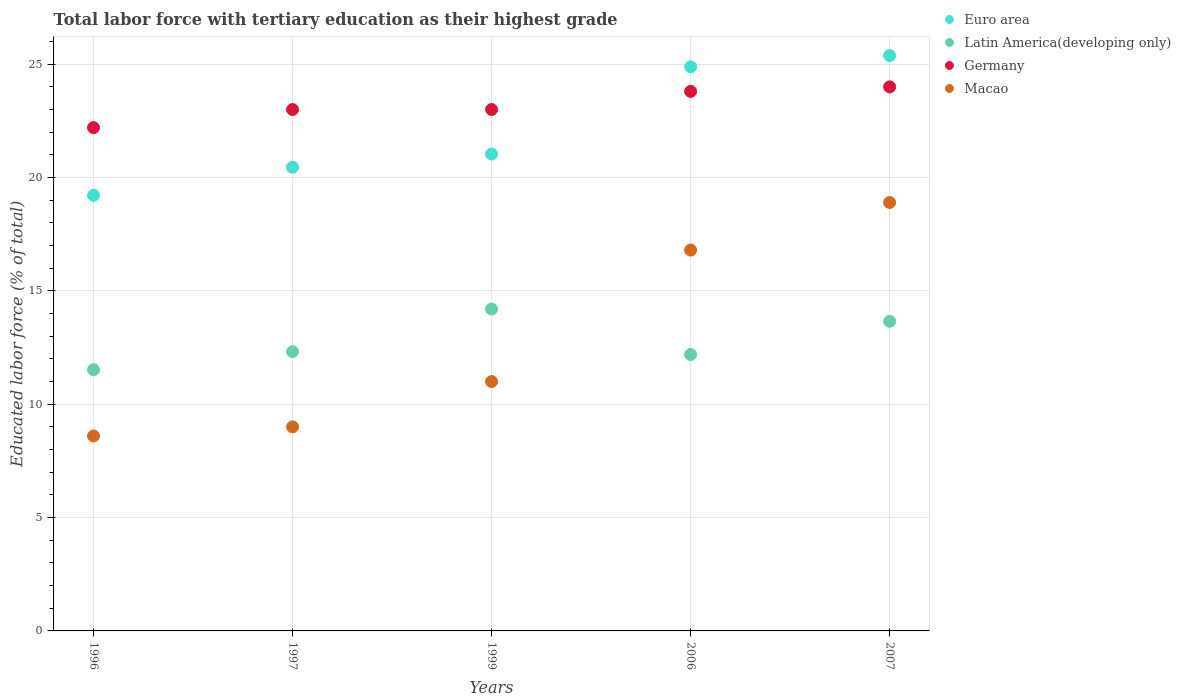How many different coloured dotlines are there?
Ensure brevity in your answer.  4. What is the percentage of male labor force with tertiary education in Latin America(developing only) in 1997?
Keep it short and to the point. 12.32. Across all years, what is the maximum percentage of male labor force with tertiary education in Macao?
Give a very brief answer. 18.9. Across all years, what is the minimum percentage of male labor force with tertiary education in Latin America(developing only)?
Keep it short and to the point. 11.52. In which year was the percentage of male labor force with tertiary education in Latin America(developing only) minimum?
Make the answer very short. 1996. What is the total percentage of male labor force with tertiary education in Euro area in the graph?
Make the answer very short. 110.97. What is the difference between the percentage of male labor force with tertiary education in Latin America(developing only) in 1996 and that in 2007?
Provide a short and direct response. -2.13. What is the difference between the percentage of male labor force with tertiary education in Latin America(developing only) in 1997 and the percentage of male labor force with tertiary education in Macao in 1996?
Your answer should be very brief. 3.72. What is the average percentage of male labor force with tertiary education in Latin America(developing only) per year?
Keep it short and to the point. 12.78. In the year 2006, what is the difference between the percentage of male labor force with tertiary education in Euro area and percentage of male labor force with tertiary education in Macao?
Make the answer very short. 8.08. What is the ratio of the percentage of male labor force with tertiary education in Germany in 1999 to that in 2006?
Your answer should be compact. 0.97. Is the percentage of male labor force with tertiary education in Euro area in 1997 less than that in 2006?
Provide a short and direct response. Yes. Is the difference between the percentage of male labor force with tertiary education in Euro area in 1996 and 2006 greater than the difference between the percentage of male labor force with tertiary education in Macao in 1996 and 2006?
Keep it short and to the point. Yes. What is the difference between the highest and the second highest percentage of male labor force with tertiary education in Latin America(developing only)?
Your answer should be very brief. 0.54. What is the difference between the highest and the lowest percentage of male labor force with tertiary education in Macao?
Provide a succinct answer. 10.3. Is it the case that in every year, the sum of the percentage of male labor force with tertiary education in Euro area and percentage of male labor force with tertiary education in Germany  is greater than the sum of percentage of male labor force with tertiary education in Latin America(developing only) and percentage of male labor force with tertiary education in Macao?
Your response must be concise. Yes. Is it the case that in every year, the sum of the percentage of male labor force with tertiary education in Germany and percentage of male labor force with tertiary education in Euro area  is greater than the percentage of male labor force with tertiary education in Macao?
Your answer should be very brief. Yes. Does the percentage of male labor force with tertiary education in Germany monotonically increase over the years?
Your response must be concise. No. Is the percentage of male labor force with tertiary education in Euro area strictly less than the percentage of male labor force with tertiary education in Macao over the years?
Keep it short and to the point. No. Are the values on the major ticks of Y-axis written in scientific E-notation?
Your answer should be very brief. No. Does the graph contain any zero values?
Your answer should be compact. No. Where does the legend appear in the graph?
Your answer should be very brief. Top right. What is the title of the graph?
Make the answer very short. Total labor force with tertiary education as their highest grade. What is the label or title of the X-axis?
Give a very brief answer. Years. What is the label or title of the Y-axis?
Keep it short and to the point. Educated labor force (% of total). What is the Educated labor force (% of total) of Euro area in 1996?
Keep it short and to the point. 19.22. What is the Educated labor force (% of total) in Latin America(developing only) in 1996?
Make the answer very short. 11.52. What is the Educated labor force (% of total) in Germany in 1996?
Give a very brief answer. 22.2. What is the Educated labor force (% of total) in Macao in 1996?
Make the answer very short. 8.6. What is the Educated labor force (% of total) in Euro area in 1997?
Provide a short and direct response. 20.46. What is the Educated labor force (% of total) of Latin America(developing only) in 1997?
Make the answer very short. 12.32. What is the Educated labor force (% of total) of Germany in 1997?
Provide a succinct answer. 23. What is the Educated labor force (% of total) of Macao in 1997?
Keep it short and to the point. 9. What is the Educated labor force (% of total) of Euro area in 1999?
Ensure brevity in your answer.  21.03. What is the Educated labor force (% of total) in Latin America(developing only) in 1999?
Keep it short and to the point. 14.2. What is the Educated labor force (% of total) in Germany in 1999?
Your answer should be very brief. 23. What is the Educated labor force (% of total) in Macao in 1999?
Your response must be concise. 11. What is the Educated labor force (% of total) in Euro area in 2006?
Provide a short and direct response. 24.88. What is the Educated labor force (% of total) in Latin America(developing only) in 2006?
Your response must be concise. 12.19. What is the Educated labor force (% of total) in Germany in 2006?
Provide a succinct answer. 23.8. What is the Educated labor force (% of total) in Macao in 2006?
Offer a terse response. 16.8. What is the Educated labor force (% of total) of Euro area in 2007?
Offer a very short reply. 25.38. What is the Educated labor force (% of total) in Latin America(developing only) in 2007?
Ensure brevity in your answer.  13.66. What is the Educated labor force (% of total) in Germany in 2007?
Offer a terse response. 24. What is the Educated labor force (% of total) in Macao in 2007?
Provide a short and direct response. 18.9. Across all years, what is the maximum Educated labor force (% of total) of Euro area?
Your answer should be very brief. 25.38. Across all years, what is the maximum Educated labor force (% of total) of Latin America(developing only)?
Offer a terse response. 14.2. Across all years, what is the maximum Educated labor force (% of total) in Macao?
Offer a terse response. 18.9. Across all years, what is the minimum Educated labor force (% of total) of Euro area?
Provide a short and direct response. 19.22. Across all years, what is the minimum Educated labor force (% of total) of Latin America(developing only)?
Make the answer very short. 11.52. Across all years, what is the minimum Educated labor force (% of total) in Germany?
Offer a terse response. 22.2. Across all years, what is the minimum Educated labor force (% of total) in Macao?
Ensure brevity in your answer.  8.6. What is the total Educated labor force (% of total) in Euro area in the graph?
Your answer should be very brief. 110.97. What is the total Educated labor force (% of total) in Latin America(developing only) in the graph?
Provide a succinct answer. 63.89. What is the total Educated labor force (% of total) in Germany in the graph?
Give a very brief answer. 116. What is the total Educated labor force (% of total) of Macao in the graph?
Offer a very short reply. 64.3. What is the difference between the Educated labor force (% of total) in Euro area in 1996 and that in 1997?
Give a very brief answer. -1.24. What is the difference between the Educated labor force (% of total) in Latin America(developing only) in 1996 and that in 1997?
Ensure brevity in your answer.  -0.8. What is the difference between the Educated labor force (% of total) of Germany in 1996 and that in 1997?
Offer a very short reply. -0.8. What is the difference between the Educated labor force (% of total) of Macao in 1996 and that in 1997?
Your response must be concise. -0.4. What is the difference between the Educated labor force (% of total) in Euro area in 1996 and that in 1999?
Make the answer very short. -1.82. What is the difference between the Educated labor force (% of total) in Latin America(developing only) in 1996 and that in 1999?
Your response must be concise. -2.68. What is the difference between the Educated labor force (% of total) of Euro area in 1996 and that in 2006?
Your answer should be very brief. -5.67. What is the difference between the Educated labor force (% of total) in Latin America(developing only) in 1996 and that in 2006?
Your response must be concise. -0.67. What is the difference between the Educated labor force (% of total) of Germany in 1996 and that in 2006?
Ensure brevity in your answer.  -1.6. What is the difference between the Educated labor force (% of total) of Macao in 1996 and that in 2006?
Keep it short and to the point. -8.2. What is the difference between the Educated labor force (% of total) in Euro area in 1996 and that in 2007?
Provide a short and direct response. -6.16. What is the difference between the Educated labor force (% of total) in Latin America(developing only) in 1996 and that in 2007?
Your response must be concise. -2.13. What is the difference between the Educated labor force (% of total) of Germany in 1996 and that in 2007?
Provide a short and direct response. -1.8. What is the difference between the Educated labor force (% of total) in Euro area in 1997 and that in 1999?
Provide a short and direct response. -0.58. What is the difference between the Educated labor force (% of total) in Latin America(developing only) in 1997 and that in 1999?
Offer a very short reply. -1.88. What is the difference between the Educated labor force (% of total) of Euro area in 1997 and that in 2006?
Give a very brief answer. -4.43. What is the difference between the Educated labor force (% of total) of Latin America(developing only) in 1997 and that in 2006?
Offer a very short reply. 0.13. What is the difference between the Educated labor force (% of total) of Euro area in 1997 and that in 2007?
Ensure brevity in your answer.  -4.92. What is the difference between the Educated labor force (% of total) in Latin America(developing only) in 1997 and that in 2007?
Give a very brief answer. -1.34. What is the difference between the Educated labor force (% of total) in Euro area in 1999 and that in 2006?
Provide a succinct answer. -3.85. What is the difference between the Educated labor force (% of total) in Latin America(developing only) in 1999 and that in 2006?
Give a very brief answer. 2.01. What is the difference between the Educated labor force (% of total) in Euro area in 1999 and that in 2007?
Offer a terse response. -4.34. What is the difference between the Educated labor force (% of total) in Latin America(developing only) in 1999 and that in 2007?
Provide a succinct answer. 0.54. What is the difference between the Educated labor force (% of total) in Euro area in 2006 and that in 2007?
Give a very brief answer. -0.49. What is the difference between the Educated labor force (% of total) in Latin America(developing only) in 2006 and that in 2007?
Ensure brevity in your answer.  -1.46. What is the difference between the Educated labor force (% of total) in Macao in 2006 and that in 2007?
Provide a short and direct response. -2.1. What is the difference between the Educated labor force (% of total) of Euro area in 1996 and the Educated labor force (% of total) of Latin America(developing only) in 1997?
Provide a succinct answer. 6.9. What is the difference between the Educated labor force (% of total) of Euro area in 1996 and the Educated labor force (% of total) of Germany in 1997?
Offer a terse response. -3.78. What is the difference between the Educated labor force (% of total) in Euro area in 1996 and the Educated labor force (% of total) in Macao in 1997?
Ensure brevity in your answer.  10.22. What is the difference between the Educated labor force (% of total) in Latin America(developing only) in 1996 and the Educated labor force (% of total) in Germany in 1997?
Your answer should be very brief. -11.48. What is the difference between the Educated labor force (% of total) of Latin America(developing only) in 1996 and the Educated labor force (% of total) of Macao in 1997?
Make the answer very short. 2.52. What is the difference between the Educated labor force (% of total) of Euro area in 1996 and the Educated labor force (% of total) of Latin America(developing only) in 1999?
Make the answer very short. 5.02. What is the difference between the Educated labor force (% of total) of Euro area in 1996 and the Educated labor force (% of total) of Germany in 1999?
Ensure brevity in your answer.  -3.78. What is the difference between the Educated labor force (% of total) of Euro area in 1996 and the Educated labor force (% of total) of Macao in 1999?
Provide a short and direct response. 8.22. What is the difference between the Educated labor force (% of total) of Latin America(developing only) in 1996 and the Educated labor force (% of total) of Germany in 1999?
Provide a succinct answer. -11.48. What is the difference between the Educated labor force (% of total) of Latin America(developing only) in 1996 and the Educated labor force (% of total) of Macao in 1999?
Your response must be concise. 0.52. What is the difference between the Educated labor force (% of total) of Euro area in 1996 and the Educated labor force (% of total) of Latin America(developing only) in 2006?
Make the answer very short. 7.02. What is the difference between the Educated labor force (% of total) in Euro area in 1996 and the Educated labor force (% of total) in Germany in 2006?
Offer a terse response. -4.58. What is the difference between the Educated labor force (% of total) in Euro area in 1996 and the Educated labor force (% of total) in Macao in 2006?
Give a very brief answer. 2.42. What is the difference between the Educated labor force (% of total) of Latin America(developing only) in 1996 and the Educated labor force (% of total) of Germany in 2006?
Ensure brevity in your answer.  -12.28. What is the difference between the Educated labor force (% of total) in Latin America(developing only) in 1996 and the Educated labor force (% of total) in Macao in 2006?
Your answer should be very brief. -5.28. What is the difference between the Educated labor force (% of total) of Euro area in 1996 and the Educated labor force (% of total) of Latin America(developing only) in 2007?
Your answer should be very brief. 5.56. What is the difference between the Educated labor force (% of total) in Euro area in 1996 and the Educated labor force (% of total) in Germany in 2007?
Offer a very short reply. -4.78. What is the difference between the Educated labor force (% of total) in Euro area in 1996 and the Educated labor force (% of total) in Macao in 2007?
Your answer should be compact. 0.32. What is the difference between the Educated labor force (% of total) in Latin America(developing only) in 1996 and the Educated labor force (% of total) in Germany in 2007?
Offer a terse response. -12.48. What is the difference between the Educated labor force (% of total) of Latin America(developing only) in 1996 and the Educated labor force (% of total) of Macao in 2007?
Keep it short and to the point. -7.38. What is the difference between the Educated labor force (% of total) of Germany in 1996 and the Educated labor force (% of total) of Macao in 2007?
Your answer should be very brief. 3.3. What is the difference between the Educated labor force (% of total) in Euro area in 1997 and the Educated labor force (% of total) in Latin America(developing only) in 1999?
Offer a very short reply. 6.26. What is the difference between the Educated labor force (% of total) of Euro area in 1997 and the Educated labor force (% of total) of Germany in 1999?
Your response must be concise. -2.54. What is the difference between the Educated labor force (% of total) in Euro area in 1997 and the Educated labor force (% of total) in Macao in 1999?
Offer a terse response. 9.46. What is the difference between the Educated labor force (% of total) of Latin America(developing only) in 1997 and the Educated labor force (% of total) of Germany in 1999?
Provide a short and direct response. -10.68. What is the difference between the Educated labor force (% of total) of Latin America(developing only) in 1997 and the Educated labor force (% of total) of Macao in 1999?
Offer a terse response. 1.32. What is the difference between the Educated labor force (% of total) of Germany in 1997 and the Educated labor force (% of total) of Macao in 1999?
Give a very brief answer. 12. What is the difference between the Educated labor force (% of total) in Euro area in 1997 and the Educated labor force (% of total) in Latin America(developing only) in 2006?
Offer a very short reply. 8.26. What is the difference between the Educated labor force (% of total) of Euro area in 1997 and the Educated labor force (% of total) of Germany in 2006?
Your answer should be very brief. -3.34. What is the difference between the Educated labor force (% of total) in Euro area in 1997 and the Educated labor force (% of total) in Macao in 2006?
Offer a terse response. 3.66. What is the difference between the Educated labor force (% of total) of Latin America(developing only) in 1997 and the Educated labor force (% of total) of Germany in 2006?
Offer a terse response. -11.48. What is the difference between the Educated labor force (% of total) of Latin America(developing only) in 1997 and the Educated labor force (% of total) of Macao in 2006?
Your response must be concise. -4.48. What is the difference between the Educated labor force (% of total) of Euro area in 1997 and the Educated labor force (% of total) of Latin America(developing only) in 2007?
Offer a terse response. 6.8. What is the difference between the Educated labor force (% of total) in Euro area in 1997 and the Educated labor force (% of total) in Germany in 2007?
Offer a terse response. -3.54. What is the difference between the Educated labor force (% of total) in Euro area in 1997 and the Educated labor force (% of total) in Macao in 2007?
Ensure brevity in your answer.  1.56. What is the difference between the Educated labor force (% of total) of Latin America(developing only) in 1997 and the Educated labor force (% of total) of Germany in 2007?
Provide a short and direct response. -11.68. What is the difference between the Educated labor force (% of total) in Latin America(developing only) in 1997 and the Educated labor force (% of total) in Macao in 2007?
Provide a succinct answer. -6.58. What is the difference between the Educated labor force (% of total) of Germany in 1997 and the Educated labor force (% of total) of Macao in 2007?
Make the answer very short. 4.1. What is the difference between the Educated labor force (% of total) of Euro area in 1999 and the Educated labor force (% of total) of Latin America(developing only) in 2006?
Your response must be concise. 8.84. What is the difference between the Educated labor force (% of total) of Euro area in 1999 and the Educated labor force (% of total) of Germany in 2006?
Your answer should be very brief. -2.77. What is the difference between the Educated labor force (% of total) of Euro area in 1999 and the Educated labor force (% of total) of Macao in 2006?
Your answer should be compact. 4.23. What is the difference between the Educated labor force (% of total) in Latin America(developing only) in 1999 and the Educated labor force (% of total) in Germany in 2006?
Make the answer very short. -9.6. What is the difference between the Educated labor force (% of total) of Latin America(developing only) in 1999 and the Educated labor force (% of total) of Macao in 2006?
Your answer should be very brief. -2.6. What is the difference between the Educated labor force (% of total) in Germany in 1999 and the Educated labor force (% of total) in Macao in 2006?
Keep it short and to the point. 6.2. What is the difference between the Educated labor force (% of total) in Euro area in 1999 and the Educated labor force (% of total) in Latin America(developing only) in 2007?
Provide a short and direct response. 7.38. What is the difference between the Educated labor force (% of total) in Euro area in 1999 and the Educated labor force (% of total) in Germany in 2007?
Ensure brevity in your answer.  -2.97. What is the difference between the Educated labor force (% of total) in Euro area in 1999 and the Educated labor force (% of total) in Macao in 2007?
Offer a very short reply. 2.13. What is the difference between the Educated labor force (% of total) in Latin America(developing only) in 1999 and the Educated labor force (% of total) in Germany in 2007?
Keep it short and to the point. -9.8. What is the difference between the Educated labor force (% of total) of Latin America(developing only) in 1999 and the Educated labor force (% of total) of Macao in 2007?
Offer a very short reply. -4.7. What is the difference between the Educated labor force (% of total) in Euro area in 2006 and the Educated labor force (% of total) in Latin America(developing only) in 2007?
Provide a short and direct response. 11.23. What is the difference between the Educated labor force (% of total) in Euro area in 2006 and the Educated labor force (% of total) in Germany in 2007?
Offer a terse response. 0.88. What is the difference between the Educated labor force (% of total) in Euro area in 2006 and the Educated labor force (% of total) in Macao in 2007?
Your answer should be compact. 5.98. What is the difference between the Educated labor force (% of total) of Latin America(developing only) in 2006 and the Educated labor force (% of total) of Germany in 2007?
Ensure brevity in your answer.  -11.81. What is the difference between the Educated labor force (% of total) of Latin America(developing only) in 2006 and the Educated labor force (% of total) of Macao in 2007?
Keep it short and to the point. -6.71. What is the average Educated labor force (% of total) in Euro area per year?
Your response must be concise. 22.19. What is the average Educated labor force (% of total) in Latin America(developing only) per year?
Provide a succinct answer. 12.78. What is the average Educated labor force (% of total) in Germany per year?
Ensure brevity in your answer.  23.2. What is the average Educated labor force (% of total) in Macao per year?
Your answer should be very brief. 12.86. In the year 1996, what is the difference between the Educated labor force (% of total) in Euro area and Educated labor force (% of total) in Latin America(developing only)?
Keep it short and to the point. 7.69. In the year 1996, what is the difference between the Educated labor force (% of total) of Euro area and Educated labor force (% of total) of Germany?
Offer a terse response. -2.98. In the year 1996, what is the difference between the Educated labor force (% of total) of Euro area and Educated labor force (% of total) of Macao?
Provide a short and direct response. 10.62. In the year 1996, what is the difference between the Educated labor force (% of total) in Latin America(developing only) and Educated labor force (% of total) in Germany?
Give a very brief answer. -10.68. In the year 1996, what is the difference between the Educated labor force (% of total) of Latin America(developing only) and Educated labor force (% of total) of Macao?
Provide a succinct answer. 2.92. In the year 1997, what is the difference between the Educated labor force (% of total) in Euro area and Educated labor force (% of total) in Latin America(developing only)?
Your response must be concise. 8.14. In the year 1997, what is the difference between the Educated labor force (% of total) in Euro area and Educated labor force (% of total) in Germany?
Ensure brevity in your answer.  -2.54. In the year 1997, what is the difference between the Educated labor force (% of total) of Euro area and Educated labor force (% of total) of Macao?
Keep it short and to the point. 11.46. In the year 1997, what is the difference between the Educated labor force (% of total) in Latin America(developing only) and Educated labor force (% of total) in Germany?
Provide a short and direct response. -10.68. In the year 1997, what is the difference between the Educated labor force (% of total) of Latin America(developing only) and Educated labor force (% of total) of Macao?
Provide a short and direct response. 3.32. In the year 1999, what is the difference between the Educated labor force (% of total) in Euro area and Educated labor force (% of total) in Latin America(developing only)?
Your answer should be compact. 6.84. In the year 1999, what is the difference between the Educated labor force (% of total) of Euro area and Educated labor force (% of total) of Germany?
Your answer should be very brief. -1.97. In the year 1999, what is the difference between the Educated labor force (% of total) in Euro area and Educated labor force (% of total) in Macao?
Provide a succinct answer. 10.03. In the year 1999, what is the difference between the Educated labor force (% of total) in Latin America(developing only) and Educated labor force (% of total) in Germany?
Your response must be concise. -8.8. In the year 1999, what is the difference between the Educated labor force (% of total) of Latin America(developing only) and Educated labor force (% of total) of Macao?
Provide a succinct answer. 3.2. In the year 2006, what is the difference between the Educated labor force (% of total) in Euro area and Educated labor force (% of total) in Latin America(developing only)?
Offer a very short reply. 12.69. In the year 2006, what is the difference between the Educated labor force (% of total) in Euro area and Educated labor force (% of total) in Germany?
Offer a terse response. 1.08. In the year 2006, what is the difference between the Educated labor force (% of total) in Euro area and Educated labor force (% of total) in Macao?
Ensure brevity in your answer.  8.08. In the year 2006, what is the difference between the Educated labor force (% of total) in Latin America(developing only) and Educated labor force (% of total) in Germany?
Give a very brief answer. -11.61. In the year 2006, what is the difference between the Educated labor force (% of total) in Latin America(developing only) and Educated labor force (% of total) in Macao?
Provide a succinct answer. -4.61. In the year 2007, what is the difference between the Educated labor force (% of total) in Euro area and Educated labor force (% of total) in Latin America(developing only)?
Your response must be concise. 11.72. In the year 2007, what is the difference between the Educated labor force (% of total) of Euro area and Educated labor force (% of total) of Germany?
Keep it short and to the point. 1.38. In the year 2007, what is the difference between the Educated labor force (% of total) of Euro area and Educated labor force (% of total) of Macao?
Provide a short and direct response. 6.48. In the year 2007, what is the difference between the Educated labor force (% of total) in Latin America(developing only) and Educated labor force (% of total) in Germany?
Give a very brief answer. -10.34. In the year 2007, what is the difference between the Educated labor force (% of total) in Latin America(developing only) and Educated labor force (% of total) in Macao?
Your answer should be very brief. -5.24. In the year 2007, what is the difference between the Educated labor force (% of total) of Germany and Educated labor force (% of total) of Macao?
Provide a succinct answer. 5.1. What is the ratio of the Educated labor force (% of total) of Euro area in 1996 to that in 1997?
Your response must be concise. 0.94. What is the ratio of the Educated labor force (% of total) in Latin America(developing only) in 1996 to that in 1997?
Give a very brief answer. 0.94. What is the ratio of the Educated labor force (% of total) in Germany in 1996 to that in 1997?
Keep it short and to the point. 0.97. What is the ratio of the Educated labor force (% of total) in Macao in 1996 to that in 1997?
Your answer should be compact. 0.96. What is the ratio of the Educated labor force (% of total) in Euro area in 1996 to that in 1999?
Offer a very short reply. 0.91. What is the ratio of the Educated labor force (% of total) of Latin America(developing only) in 1996 to that in 1999?
Your answer should be compact. 0.81. What is the ratio of the Educated labor force (% of total) of Germany in 1996 to that in 1999?
Offer a terse response. 0.97. What is the ratio of the Educated labor force (% of total) of Macao in 1996 to that in 1999?
Your response must be concise. 0.78. What is the ratio of the Educated labor force (% of total) in Euro area in 1996 to that in 2006?
Offer a terse response. 0.77. What is the ratio of the Educated labor force (% of total) in Latin America(developing only) in 1996 to that in 2006?
Give a very brief answer. 0.95. What is the ratio of the Educated labor force (% of total) of Germany in 1996 to that in 2006?
Ensure brevity in your answer.  0.93. What is the ratio of the Educated labor force (% of total) in Macao in 1996 to that in 2006?
Offer a terse response. 0.51. What is the ratio of the Educated labor force (% of total) of Euro area in 1996 to that in 2007?
Keep it short and to the point. 0.76. What is the ratio of the Educated labor force (% of total) of Latin America(developing only) in 1996 to that in 2007?
Your response must be concise. 0.84. What is the ratio of the Educated labor force (% of total) of Germany in 1996 to that in 2007?
Ensure brevity in your answer.  0.93. What is the ratio of the Educated labor force (% of total) in Macao in 1996 to that in 2007?
Your answer should be compact. 0.46. What is the ratio of the Educated labor force (% of total) in Euro area in 1997 to that in 1999?
Offer a terse response. 0.97. What is the ratio of the Educated labor force (% of total) in Latin America(developing only) in 1997 to that in 1999?
Your response must be concise. 0.87. What is the ratio of the Educated labor force (% of total) in Macao in 1997 to that in 1999?
Provide a succinct answer. 0.82. What is the ratio of the Educated labor force (% of total) of Euro area in 1997 to that in 2006?
Provide a succinct answer. 0.82. What is the ratio of the Educated labor force (% of total) of Latin America(developing only) in 1997 to that in 2006?
Provide a short and direct response. 1.01. What is the ratio of the Educated labor force (% of total) in Germany in 1997 to that in 2006?
Your answer should be compact. 0.97. What is the ratio of the Educated labor force (% of total) in Macao in 1997 to that in 2006?
Offer a very short reply. 0.54. What is the ratio of the Educated labor force (% of total) of Euro area in 1997 to that in 2007?
Your response must be concise. 0.81. What is the ratio of the Educated labor force (% of total) in Latin America(developing only) in 1997 to that in 2007?
Your answer should be very brief. 0.9. What is the ratio of the Educated labor force (% of total) in Macao in 1997 to that in 2007?
Provide a succinct answer. 0.48. What is the ratio of the Educated labor force (% of total) in Euro area in 1999 to that in 2006?
Make the answer very short. 0.85. What is the ratio of the Educated labor force (% of total) of Latin America(developing only) in 1999 to that in 2006?
Provide a short and direct response. 1.16. What is the ratio of the Educated labor force (% of total) in Germany in 1999 to that in 2006?
Give a very brief answer. 0.97. What is the ratio of the Educated labor force (% of total) in Macao in 1999 to that in 2006?
Your answer should be very brief. 0.65. What is the ratio of the Educated labor force (% of total) of Euro area in 1999 to that in 2007?
Provide a succinct answer. 0.83. What is the ratio of the Educated labor force (% of total) of Latin America(developing only) in 1999 to that in 2007?
Make the answer very short. 1.04. What is the ratio of the Educated labor force (% of total) in Germany in 1999 to that in 2007?
Ensure brevity in your answer.  0.96. What is the ratio of the Educated labor force (% of total) of Macao in 1999 to that in 2007?
Offer a very short reply. 0.58. What is the ratio of the Educated labor force (% of total) of Euro area in 2006 to that in 2007?
Your answer should be very brief. 0.98. What is the ratio of the Educated labor force (% of total) in Latin America(developing only) in 2006 to that in 2007?
Give a very brief answer. 0.89. What is the ratio of the Educated labor force (% of total) in Macao in 2006 to that in 2007?
Offer a very short reply. 0.89. What is the difference between the highest and the second highest Educated labor force (% of total) in Euro area?
Your response must be concise. 0.49. What is the difference between the highest and the second highest Educated labor force (% of total) in Latin America(developing only)?
Offer a terse response. 0.54. What is the difference between the highest and the lowest Educated labor force (% of total) in Euro area?
Offer a very short reply. 6.16. What is the difference between the highest and the lowest Educated labor force (% of total) of Latin America(developing only)?
Provide a short and direct response. 2.68. 